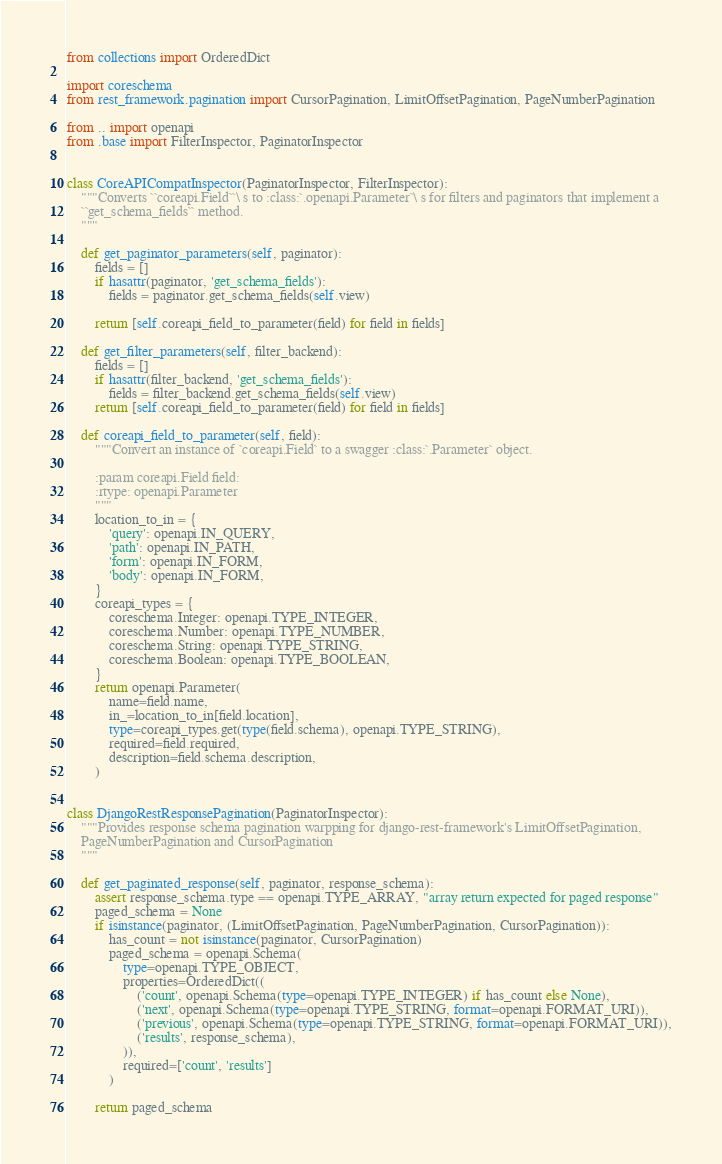<code> <loc_0><loc_0><loc_500><loc_500><_Python_>from collections import OrderedDict

import coreschema
from rest_framework.pagination import CursorPagination, LimitOffsetPagination, PageNumberPagination

from .. import openapi
from .base import FilterInspector, PaginatorInspector


class CoreAPICompatInspector(PaginatorInspector, FilterInspector):
    """Converts ``coreapi.Field``\ s to :class:`.openapi.Parameter`\ s for filters and paginators that implement a
    ``get_schema_fields`` method.
    """

    def get_paginator_parameters(self, paginator):
        fields = []
        if hasattr(paginator, 'get_schema_fields'):
            fields = paginator.get_schema_fields(self.view)

        return [self.coreapi_field_to_parameter(field) for field in fields]

    def get_filter_parameters(self, filter_backend):
        fields = []
        if hasattr(filter_backend, 'get_schema_fields'):
            fields = filter_backend.get_schema_fields(self.view)
        return [self.coreapi_field_to_parameter(field) for field in fields]

    def coreapi_field_to_parameter(self, field):
        """Convert an instance of `coreapi.Field` to a swagger :class:`.Parameter` object.

        :param coreapi.Field field:
        :rtype: openapi.Parameter
        """
        location_to_in = {
            'query': openapi.IN_QUERY,
            'path': openapi.IN_PATH,
            'form': openapi.IN_FORM,
            'body': openapi.IN_FORM,
        }
        coreapi_types = {
            coreschema.Integer: openapi.TYPE_INTEGER,
            coreschema.Number: openapi.TYPE_NUMBER,
            coreschema.String: openapi.TYPE_STRING,
            coreschema.Boolean: openapi.TYPE_BOOLEAN,
        }
        return openapi.Parameter(
            name=field.name,
            in_=location_to_in[field.location],
            type=coreapi_types.get(type(field.schema), openapi.TYPE_STRING),
            required=field.required,
            description=field.schema.description,
        )


class DjangoRestResponsePagination(PaginatorInspector):
    """Provides response schema pagination warpping for django-rest-framework's LimitOffsetPagination,
    PageNumberPagination and CursorPagination
    """

    def get_paginated_response(self, paginator, response_schema):
        assert response_schema.type == openapi.TYPE_ARRAY, "array return expected for paged response"
        paged_schema = None
        if isinstance(paginator, (LimitOffsetPagination, PageNumberPagination, CursorPagination)):
            has_count = not isinstance(paginator, CursorPagination)
            paged_schema = openapi.Schema(
                type=openapi.TYPE_OBJECT,
                properties=OrderedDict((
                    ('count', openapi.Schema(type=openapi.TYPE_INTEGER) if has_count else None),
                    ('next', openapi.Schema(type=openapi.TYPE_STRING, format=openapi.FORMAT_URI)),
                    ('previous', openapi.Schema(type=openapi.TYPE_STRING, format=openapi.FORMAT_URI)),
                    ('results', response_schema),
                )),
                required=['count', 'results']
            )

        return paged_schema
</code> 